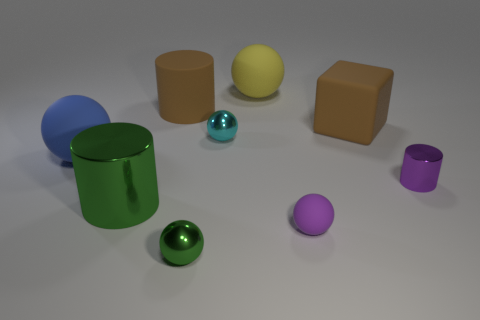Is the large ball that is on the right side of the cyan metallic object made of the same material as the purple cylinder?
Your answer should be very brief. No. What shape is the purple rubber object that is the same size as the green shiny sphere?
Offer a very short reply. Sphere. What number of large shiny objects are the same color as the big matte cylinder?
Provide a short and direct response. 0. Is the number of blue matte spheres that are on the right side of the large shiny cylinder less than the number of blue rubber objects in front of the tiny shiny cylinder?
Provide a succinct answer. No. Are there any small objects in front of the tiny purple metal thing?
Your answer should be very brief. Yes. There is a metallic cylinder on the right side of the large cylinder in front of the big matte cylinder; is there a matte cylinder in front of it?
Ensure brevity in your answer.  No. Is the shape of the yellow rubber object that is on the right side of the big blue rubber thing the same as  the tiny cyan object?
Keep it short and to the point. Yes. There is a large cylinder that is the same material as the blue thing; what color is it?
Keep it short and to the point. Brown. How many large yellow cylinders are made of the same material as the brown cylinder?
Provide a succinct answer. 0. There is a rubber thing that is behind the cylinder that is behind the small thing that is behind the purple metallic thing; what color is it?
Your answer should be compact. Yellow. 